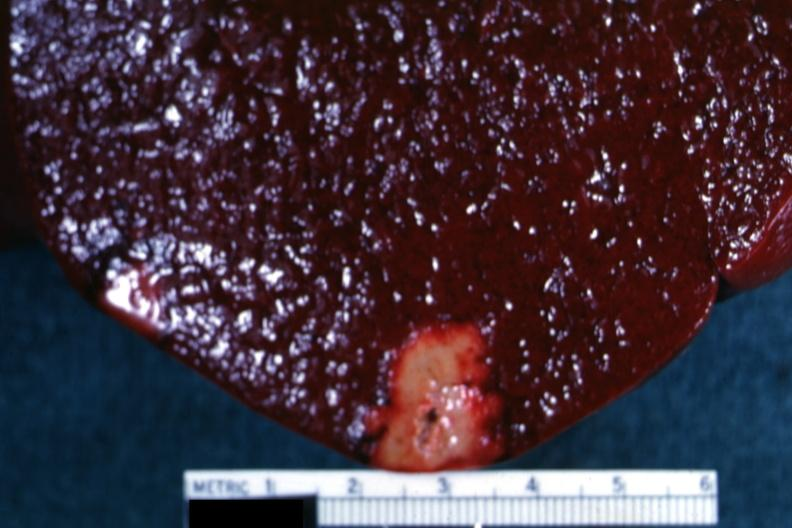s spleen present?
Answer the question using a single word or phrase. Yes 